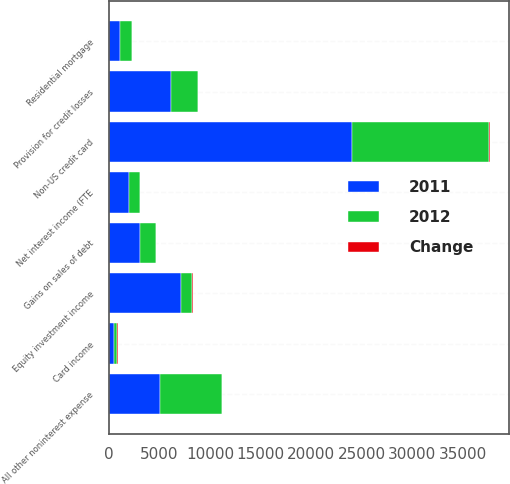Convert chart. <chart><loc_0><loc_0><loc_500><loc_500><stacked_bar_chart><ecel><fcel>Net interest income (FTE<fcel>Card income<fcel>Equity investment income<fcel>Gains on sales of debt<fcel>Provision for credit losses<fcel>All other noninterest expense<fcel>Residential mortgage<fcel>Non-US credit card<nl><fcel>2012<fcel>1111<fcel>360<fcel>1135<fcel>1510<fcel>2620<fcel>6092<fcel>1123<fcel>13549<nl><fcel>2011<fcel>1946<fcel>465<fcel>7105<fcel>3097<fcel>6172<fcel>5034<fcel>1123<fcel>24049<nl><fcel>Change<fcel>43<fcel>23<fcel>84<fcel>51<fcel>58<fcel>21<fcel>6<fcel>44<nl></chart> 